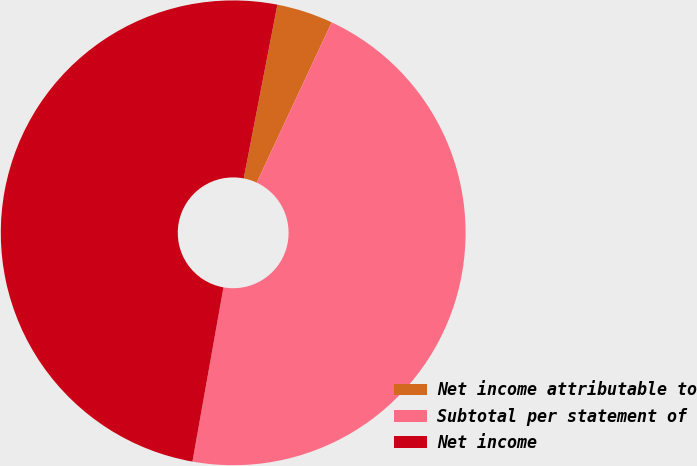Convert chart to OTSL. <chart><loc_0><loc_0><loc_500><loc_500><pie_chart><fcel>Net income attributable to<fcel>Subtotal per statement of<fcel>Net income<nl><fcel>3.92%<fcel>45.84%<fcel>50.24%<nl></chart> 